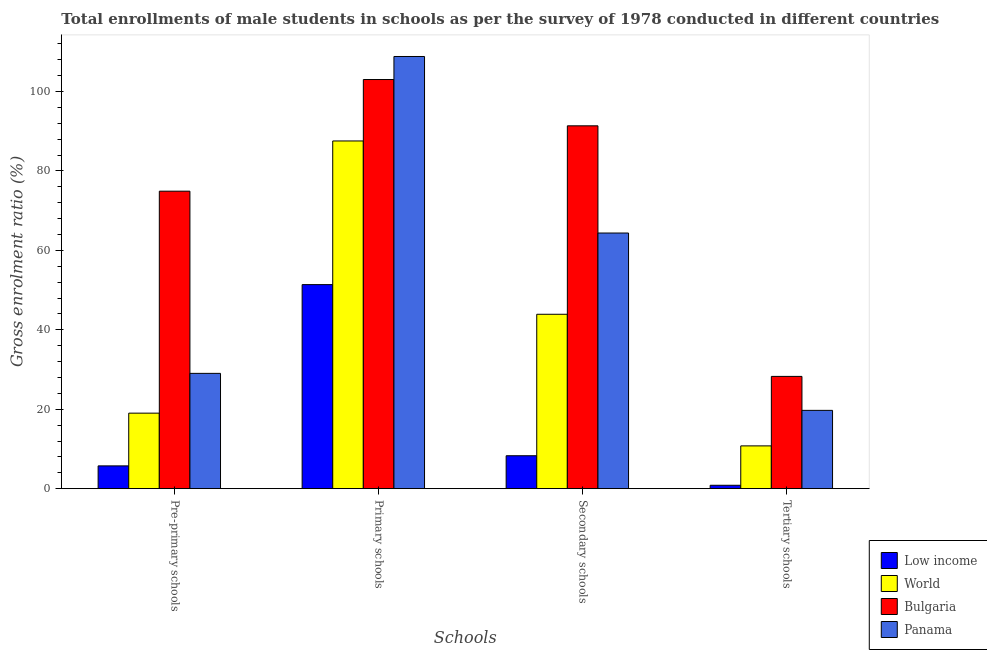How many different coloured bars are there?
Your response must be concise. 4. Are the number of bars on each tick of the X-axis equal?
Give a very brief answer. Yes. How many bars are there on the 3rd tick from the left?
Offer a terse response. 4. What is the label of the 4th group of bars from the left?
Your answer should be compact. Tertiary schools. What is the gross enrolment ratio(male) in pre-primary schools in Panama?
Provide a succinct answer. 29.03. Across all countries, what is the maximum gross enrolment ratio(male) in pre-primary schools?
Keep it short and to the point. 74.89. Across all countries, what is the minimum gross enrolment ratio(male) in secondary schools?
Your answer should be very brief. 8.29. What is the total gross enrolment ratio(male) in tertiary schools in the graph?
Your response must be concise. 59.61. What is the difference between the gross enrolment ratio(male) in primary schools in World and that in Low income?
Keep it short and to the point. 36.16. What is the difference between the gross enrolment ratio(male) in primary schools in Panama and the gross enrolment ratio(male) in secondary schools in World?
Your response must be concise. 64.9. What is the average gross enrolment ratio(male) in primary schools per country?
Your response must be concise. 87.68. What is the difference between the gross enrolment ratio(male) in tertiary schools and gross enrolment ratio(male) in secondary schools in Bulgaria?
Your answer should be compact. -63.08. In how many countries, is the gross enrolment ratio(male) in tertiary schools greater than 88 %?
Your response must be concise. 0. What is the ratio of the gross enrolment ratio(male) in secondary schools in Low income to that in World?
Your answer should be compact. 0.19. Is the difference between the gross enrolment ratio(male) in secondary schools in World and Low income greater than the difference between the gross enrolment ratio(male) in primary schools in World and Low income?
Your answer should be compact. No. What is the difference between the highest and the second highest gross enrolment ratio(male) in secondary schools?
Offer a very short reply. 26.99. What is the difference between the highest and the lowest gross enrolment ratio(male) in pre-primary schools?
Your response must be concise. 69.15. In how many countries, is the gross enrolment ratio(male) in pre-primary schools greater than the average gross enrolment ratio(male) in pre-primary schools taken over all countries?
Your response must be concise. 1. Is the sum of the gross enrolment ratio(male) in pre-primary schools in Bulgaria and World greater than the maximum gross enrolment ratio(male) in primary schools across all countries?
Your answer should be compact. No. What does the 2nd bar from the left in Tertiary schools represents?
Offer a very short reply. World. How many bars are there?
Keep it short and to the point. 16. What is the difference between two consecutive major ticks on the Y-axis?
Make the answer very short. 20. Are the values on the major ticks of Y-axis written in scientific E-notation?
Offer a terse response. No. Where does the legend appear in the graph?
Provide a succinct answer. Bottom right. How many legend labels are there?
Your response must be concise. 4. How are the legend labels stacked?
Provide a succinct answer. Vertical. What is the title of the graph?
Offer a terse response. Total enrollments of male students in schools as per the survey of 1978 conducted in different countries. Does "Georgia" appear as one of the legend labels in the graph?
Offer a terse response. No. What is the label or title of the X-axis?
Your response must be concise. Schools. What is the Gross enrolment ratio (%) of Low income in Pre-primary schools?
Your answer should be compact. 5.74. What is the Gross enrolment ratio (%) of World in Pre-primary schools?
Give a very brief answer. 19.01. What is the Gross enrolment ratio (%) in Bulgaria in Pre-primary schools?
Your answer should be compact. 74.89. What is the Gross enrolment ratio (%) in Panama in Pre-primary schools?
Provide a succinct answer. 29.03. What is the Gross enrolment ratio (%) of Low income in Primary schools?
Keep it short and to the point. 51.37. What is the Gross enrolment ratio (%) of World in Primary schools?
Your response must be concise. 87.53. What is the Gross enrolment ratio (%) in Bulgaria in Primary schools?
Your answer should be very brief. 103. What is the Gross enrolment ratio (%) of Panama in Primary schools?
Keep it short and to the point. 108.8. What is the Gross enrolment ratio (%) of Low income in Secondary schools?
Offer a terse response. 8.29. What is the Gross enrolment ratio (%) of World in Secondary schools?
Provide a succinct answer. 43.9. What is the Gross enrolment ratio (%) in Bulgaria in Secondary schools?
Ensure brevity in your answer.  91.35. What is the Gross enrolment ratio (%) of Panama in Secondary schools?
Offer a very short reply. 64.36. What is the Gross enrolment ratio (%) in Low income in Tertiary schools?
Keep it short and to the point. 0.86. What is the Gross enrolment ratio (%) in World in Tertiary schools?
Ensure brevity in your answer.  10.77. What is the Gross enrolment ratio (%) of Bulgaria in Tertiary schools?
Give a very brief answer. 28.26. What is the Gross enrolment ratio (%) in Panama in Tertiary schools?
Your response must be concise. 19.71. Across all Schools, what is the maximum Gross enrolment ratio (%) of Low income?
Make the answer very short. 51.37. Across all Schools, what is the maximum Gross enrolment ratio (%) of World?
Ensure brevity in your answer.  87.53. Across all Schools, what is the maximum Gross enrolment ratio (%) in Bulgaria?
Make the answer very short. 103. Across all Schools, what is the maximum Gross enrolment ratio (%) of Panama?
Provide a succinct answer. 108.8. Across all Schools, what is the minimum Gross enrolment ratio (%) of Low income?
Offer a terse response. 0.86. Across all Schools, what is the minimum Gross enrolment ratio (%) of World?
Your response must be concise. 10.77. Across all Schools, what is the minimum Gross enrolment ratio (%) of Bulgaria?
Your response must be concise. 28.26. Across all Schools, what is the minimum Gross enrolment ratio (%) of Panama?
Your answer should be compact. 19.71. What is the total Gross enrolment ratio (%) of Low income in the graph?
Provide a short and direct response. 66.26. What is the total Gross enrolment ratio (%) of World in the graph?
Keep it short and to the point. 161.23. What is the total Gross enrolment ratio (%) in Bulgaria in the graph?
Offer a terse response. 297.5. What is the total Gross enrolment ratio (%) in Panama in the graph?
Your response must be concise. 221.9. What is the difference between the Gross enrolment ratio (%) in Low income in Pre-primary schools and that in Primary schools?
Give a very brief answer. -45.63. What is the difference between the Gross enrolment ratio (%) of World in Pre-primary schools and that in Primary schools?
Your response must be concise. -68.52. What is the difference between the Gross enrolment ratio (%) in Bulgaria in Pre-primary schools and that in Primary schools?
Offer a very short reply. -28.11. What is the difference between the Gross enrolment ratio (%) in Panama in Pre-primary schools and that in Primary schools?
Ensure brevity in your answer.  -79.77. What is the difference between the Gross enrolment ratio (%) in Low income in Pre-primary schools and that in Secondary schools?
Give a very brief answer. -2.55. What is the difference between the Gross enrolment ratio (%) of World in Pre-primary schools and that in Secondary schools?
Provide a short and direct response. -24.89. What is the difference between the Gross enrolment ratio (%) of Bulgaria in Pre-primary schools and that in Secondary schools?
Provide a succinct answer. -16.46. What is the difference between the Gross enrolment ratio (%) of Panama in Pre-primary schools and that in Secondary schools?
Provide a short and direct response. -35.33. What is the difference between the Gross enrolment ratio (%) in Low income in Pre-primary schools and that in Tertiary schools?
Offer a very short reply. 4.88. What is the difference between the Gross enrolment ratio (%) of World in Pre-primary schools and that in Tertiary schools?
Offer a terse response. 8.24. What is the difference between the Gross enrolment ratio (%) of Bulgaria in Pre-primary schools and that in Tertiary schools?
Make the answer very short. 46.63. What is the difference between the Gross enrolment ratio (%) of Panama in Pre-primary schools and that in Tertiary schools?
Keep it short and to the point. 9.31. What is the difference between the Gross enrolment ratio (%) of Low income in Primary schools and that in Secondary schools?
Provide a succinct answer. 43.08. What is the difference between the Gross enrolment ratio (%) of World in Primary schools and that in Secondary schools?
Provide a short and direct response. 43.63. What is the difference between the Gross enrolment ratio (%) of Bulgaria in Primary schools and that in Secondary schools?
Offer a very short reply. 11.65. What is the difference between the Gross enrolment ratio (%) of Panama in Primary schools and that in Secondary schools?
Give a very brief answer. 44.44. What is the difference between the Gross enrolment ratio (%) in Low income in Primary schools and that in Tertiary schools?
Provide a succinct answer. 50.51. What is the difference between the Gross enrolment ratio (%) in World in Primary schools and that in Tertiary schools?
Your answer should be compact. 76.76. What is the difference between the Gross enrolment ratio (%) in Bulgaria in Primary schools and that in Tertiary schools?
Ensure brevity in your answer.  74.74. What is the difference between the Gross enrolment ratio (%) in Panama in Primary schools and that in Tertiary schools?
Your response must be concise. 89.09. What is the difference between the Gross enrolment ratio (%) in Low income in Secondary schools and that in Tertiary schools?
Ensure brevity in your answer.  7.43. What is the difference between the Gross enrolment ratio (%) of World in Secondary schools and that in Tertiary schools?
Make the answer very short. 33.13. What is the difference between the Gross enrolment ratio (%) in Bulgaria in Secondary schools and that in Tertiary schools?
Ensure brevity in your answer.  63.08. What is the difference between the Gross enrolment ratio (%) in Panama in Secondary schools and that in Tertiary schools?
Ensure brevity in your answer.  44.64. What is the difference between the Gross enrolment ratio (%) in Low income in Pre-primary schools and the Gross enrolment ratio (%) in World in Primary schools?
Provide a short and direct response. -81.8. What is the difference between the Gross enrolment ratio (%) of Low income in Pre-primary schools and the Gross enrolment ratio (%) of Bulgaria in Primary schools?
Your answer should be very brief. -97.26. What is the difference between the Gross enrolment ratio (%) of Low income in Pre-primary schools and the Gross enrolment ratio (%) of Panama in Primary schools?
Your response must be concise. -103.06. What is the difference between the Gross enrolment ratio (%) in World in Pre-primary schools and the Gross enrolment ratio (%) in Bulgaria in Primary schools?
Your answer should be compact. -83.99. What is the difference between the Gross enrolment ratio (%) in World in Pre-primary schools and the Gross enrolment ratio (%) in Panama in Primary schools?
Your answer should be very brief. -89.79. What is the difference between the Gross enrolment ratio (%) in Bulgaria in Pre-primary schools and the Gross enrolment ratio (%) in Panama in Primary schools?
Offer a terse response. -33.91. What is the difference between the Gross enrolment ratio (%) of Low income in Pre-primary schools and the Gross enrolment ratio (%) of World in Secondary schools?
Offer a terse response. -38.17. What is the difference between the Gross enrolment ratio (%) of Low income in Pre-primary schools and the Gross enrolment ratio (%) of Bulgaria in Secondary schools?
Keep it short and to the point. -85.61. What is the difference between the Gross enrolment ratio (%) in Low income in Pre-primary schools and the Gross enrolment ratio (%) in Panama in Secondary schools?
Provide a short and direct response. -58.62. What is the difference between the Gross enrolment ratio (%) of World in Pre-primary schools and the Gross enrolment ratio (%) of Bulgaria in Secondary schools?
Offer a very short reply. -72.33. What is the difference between the Gross enrolment ratio (%) in World in Pre-primary schools and the Gross enrolment ratio (%) in Panama in Secondary schools?
Keep it short and to the point. -45.34. What is the difference between the Gross enrolment ratio (%) in Bulgaria in Pre-primary schools and the Gross enrolment ratio (%) in Panama in Secondary schools?
Offer a terse response. 10.53. What is the difference between the Gross enrolment ratio (%) in Low income in Pre-primary schools and the Gross enrolment ratio (%) in World in Tertiary schools?
Ensure brevity in your answer.  -5.04. What is the difference between the Gross enrolment ratio (%) of Low income in Pre-primary schools and the Gross enrolment ratio (%) of Bulgaria in Tertiary schools?
Your response must be concise. -22.53. What is the difference between the Gross enrolment ratio (%) in Low income in Pre-primary schools and the Gross enrolment ratio (%) in Panama in Tertiary schools?
Provide a succinct answer. -13.98. What is the difference between the Gross enrolment ratio (%) in World in Pre-primary schools and the Gross enrolment ratio (%) in Bulgaria in Tertiary schools?
Provide a succinct answer. -9.25. What is the difference between the Gross enrolment ratio (%) in World in Pre-primary schools and the Gross enrolment ratio (%) in Panama in Tertiary schools?
Give a very brief answer. -0.7. What is the difference between the Gross enrolment ratio (%) of Bulgaria in Pre-primary schools and the Gross enrolment ratio (%) of Panama in Tertiary schools?
Offer a very short reply. 55.18. What is the difference between the Gross enrolment ratio (%) of Low income in Primary schools and the Gross enrolment ratio (%) of World in Secondary schools?
Offer a terse response. 7.47. What is the difference between the Gross enrolment ratio (%) in Low income in Primary schools and the Gross enrolment ratio (%) in Bulgaria in Secondary schools?
Ensure brevity in your answer.  -39.98. What is the difference between the Gross enrolment ratio (%) in Low income in Primary schools and the Gross enrolment ratio (%) in Panama in Secondary schools?
Make the answer very short. -12.99. What is the difference between the Gross enrolment ratio (%) of World in Primary schools and the Gross enrolment ratio (%) of Bulgaria in Secondary schools?
Your response must be concise. -3.81. What is the difference between the Gross enrolment ratio (%) in World in Primary schools and the Gross enrolment ratio (%) in Panama in Secondary schools?
Make the answer very short. 23.18. What is the difference between the Gross enrolment ratio (%) of Bulgaria in Primary schools and the Gross enrolment ratio (%) of Panama in Secondary schools?
Offer a terse response. 38.64. What is the difference between the Gross enrolment ratio (%) in Low income in Primary schools and the Gross enrolment ratio (%) in World in Tertiary schools?
Provide a short and direct response. 40.6. What is the difference between the Gross enrolment ratio (%) in Low income in Primary schools and the Gross enrolment ratio (%) in Bulgaria in Tertiary schools?
Your response must be concise. 23.11. What is the difference between the Gross enrolment ratio (%) of Low income in Primary schools and the Gross enrolment ratio (%) of Panama in Tertiary schools?
Provide a short and direct response. 31.66. What is the difference between the Gross enrolment ratio (%) of World in Primary schools and the Gross enrolment ratio (%) of Bulgaria in Tertiary schools?
Provide a short and direct response. 59.27. What is the difference between the Gross enrolment ratio (%) in World in Primary schools and the Gross enrolment ratio (%) in Panama in Tertiary schools?
Provide a short and direct response. 67.82. What is the difference between the Gross enrolment ratio (%) of Bulgaria in Primary schools and the Gross enrolment ratio (%) of Panama in Tertiary schools?
Your answer should be very brief. 83.29. What is the difference between the Gross enrolment ratio (%) of Low income in Secondary schools and the Gross enrolment ratio (%) of World in Tertiary schools?
Ensure brevity in your answer.  -2.48. What is the difference between the Gross enrolment ratio (%) in Low income in Secondary schools and the Gross enrolment ratio (%) in Bulgaria in Tertiary schools?
Offer a terse response. -19.97. What is the difference between the Gross enrolment ratio (%) of Low income in Secondary schools and the Gross enrolment ratio (%) of Panama in Tertiary schools?
Make the answer very short. -11.42. What is the difference between the Gross enrolment ratio (%) of World in Secondary schools and the Gross enrolment ratio (%) of Bulgaria in Tertiary schools?
Your response must be concise. 15.64. What is the difference between the Gross enrolment ratio (%) in World in Secondary schools and the Gross enrolment ratio (%) in Panama in Tertiary schools?
Make the answer very short. 24.19. What is the difference between the Gross enrolment ratio (%) of Bulgaria in Secondary schools and the Gross enrolment ratio (%) of Panama in Tertiary schools?
Offer a terse response. 71.63. What is the average Gross enrolment ratio (%) in Low income per Schools?
Offer a terse response. 16.56. What is the average Gross enrolment ratio (%) in World per Schools?
Offer a very short reply. 40.31. What is the average Gross enrolment ratio (%) in Bulgaria per Schools?
Provide a succinct answer. 74.38. What is the average Gross enrolment ratio (%) in Panama per Schools?
Your answer should be compact. 55.48. What is the difference between the Gross enrolment ratio (%) of Low income and Gross enrolment ratio (%) of World in Pre-primary schools?
Keep it short and to the point. -13.28. What is the difference between the Gross enrolment ratio (%) of Low income and Gross enrolment ratio (%) of Bulgaria in Pre-primary schools?
Make the answer very short. -69.15. What is the difference between the Gross enrolment ratio (%) of Low income and Gross enrolment ratio (%) of Panama in Pre-primary schools?
Your answer should be compact. -23.29. What is the difference between the Gross enrolment ratio (%) in World and Gross enrolment ratio (%) in Bulgaria in Pre-primary schools?
Offer a very short reply. -55.88. What is the difference between the Gross enrolment ratio (%) in World and Gross enrolment ratio (%) in Panama in Pre-primary schools?
Your answer should be very brief. -10.01. What is the difference between the Gross enrolment ratio (%) in Bulgaria and Gross enrolment ratio (%) in Panama in Pre-primary schools?
Provide a succinct answer. 45.86. What is the difference between the Gross enrolment ratio (%) in Low income and Gross enrolment ratio (%) in World in Primary schools?
Your answer should be very brief. -36.16. What is the difference between the Gross enrolment ratio (%) in Low income and Gross enrolment ratio (%) in Bulgaria in Primary schools?
Provide a succinct answer. -51.63. What is the difference between the Gross enrolment ratio (%) of Low income and Gross enrolment ratio (%) of Panama in Primary schools?
Your answer should be very brief. -57.43. What is the difference between the Gross enrolment ratio (%) in World and Gross enrolment ratio (%) in Bulgaria in Primary schools?
Your response must be concise. -15.47. What is the difference between the Gross enrolment ratio (%) in World and Gross enrolment ratio (%) in Panama in Primary schools?
Your answer should be compact. -21.27. What is the difference between the Gross enrolment ratio (%) in Bulgaria and Gross enrolment ratio (%) in Panama in Primary schools?
Your response must be concise. -5.8. What is the difference between the Gross enrolment ratio (%) in Low income and Gross enrolment ratio (%) in World in Secondary schools?
Your answer should be very brief. -35.61. What is the difference between the Gross enrolment ratio (%) of Low income and Gross enrolment ratio (%) of Bulgaria in Secondary schools?
Keep it short and to the point. -83.06. What is the difference between the Gross enrolment ratio (%) of Low income and Gross enrolment ratio (%) of Panama in Secondary schools?
Ensure brevity in your answer.  -56.07. What is the difference between the Gross enrolment ratio (%) of World and Gross enrolment ratio (%) of Bulgaria in Secondary schools?
Keep it short and to the point. -47.44. What is the difference between the Gross enrolment ratio (%) of World and Gross enrolment ratio (%) of Panama in Secondary schools?
Keep it short and to the point. -20.45. What is the difference between the Gross enrolment ratio (%) in Bulgaria and Gross enrolment ratio (%) in Panama in Secondary schools?
Your answer should be very brief. 26.99. What is the difference between the Gross enrolment ratio (%) in Low income and Gross enrolment ratio (%) in World in Tertiary schools?
Your answer should be compact. -9.91. What is the difference between the Gross enrolment ratio (%) of Low income and Gross enrolment ratio (%) of Bulgaria in Tertiary schools?
Your answer should be very brief. -27.41. What is the difference between the Gross enrolment ratio (%) of Low income and Gross enrolment ratio (%) of Panama in Tertiary schools?
Offer a very short reply. -18.86. What is the difference between the Gross enrolment ratio (%) in World and Gross enrolment ratio (%) in Bulgaria in Tertiary schools?
Provide a succinct answer. -17.49. What is the difference between the Gross enrolment ratio (%) of World and Gross enrolment ratio (%) of Panama in Tertiary schools?
Keep it short and to the point. -8.94. What is the difference between the Gross enrolment ratio (%) in Bulgaria and Gross enrolment ratio (%) in Panama in Tertiary schools?
Provide a short and direct response. 8.55. What is the ratio of the Gross enrolment ratio (%) of Low income in Pre-primary schools to that in Primary schools?
Ensure brevity in your answer.  0.11. What is the ratio of the Gross enrolment ratio (%) of World in Pre-primary schools to that in Primary schools?
Keep it short and to the point. 0.22. What is the ratio of the Gross enrolment ratio (%) of Bulgaria in Pre-primary schools to that in Primary schools?
Your answer should be compact. 0.73. What is the ratio of the Gross enrolment ratio (%) in Panama in Pre-primary schools to that in Primary schools?
Your answer should be very brief. 0.27. What is the ratio of the Gross enrolment ratio (%) in Low income in Pre-primary schools to that in Secondary schools?
Ensure brevity in your answer.  0.69. What is the ratio of the Gross enrolment ratio (%) of World in Pre-primary schools to that in Secondary schools?
Make the answer very short. 0.43. What is the ratio of the Gross enrolment ratio (%) of Bulgaria in Pre-primary schools to that in Secondary schools?
Provide a succinct answer. 0.82. What is the ratio of the Gross enrolment ratio (%) in Panama in Pre-primary schools to that in Secondary schools?
Offer a very short reply. 0.45. What is the ratio of the Gross enrolment ratio (%) of Low income in Pre-primary schools to that in Tertiary schools?
Ensure brevity in your answer.  6.69. What is the ratio of the Gross enrolment ratio (%) of World in Pre-primary schools to that in Tertiary schools?
Provide a succinct answer. 1.77. What is the ratio of the Gross enrolment ratio (%) of Bulgaria in Pre-primary schools to that in Tertiary schools?
Your answer should be compact. 2.65. What is the ratio of the Gross enrolment ratio (%) of Panama in Pre-primary schools to that in Tertiary schools?
Provide a succinct answer. 1.47. What is the ratio of the Gross enrolment ratio (%) in Low income in Primary schools to that in Secondary schools?
Your answer should be compact. 6.2. What is the ratio of the Gross enrolment ratio (%) of World in Primary schools to that in Secondary schools?
Provide a short and direct response. 1.99. What is the ratio of the Gross enrolment ratio (%) of Bulgaria in Primary schools to that in Secondary schools?
Offer a terse response. 1.13. What is the ratio of the Gross enrolment ratio (%) in Panama in Primary schools to that in Secondary schools?
Your response must be concise. 1.69. What is the ratio of the Gross enrolment ratio (%) in Low income in Primary schools to that in Tertiary schools?
Provide a short and direct response. 59.86. What is the ratio of the Gross enrolment ratio (%) of World in Primary schools to that in Tertiary schools?
Give a very brief answer. 8.13. What is the ratio of the Gross enrolment ratio (%) in Bulgaria in Primary schools to that in Tertiary schools?
Ensure brevity in your answer.  3.64. What is the ratio of the Gross enrolment ratio (%) in Panama in Primary schools to that in Tertiary schools?
Keep it short and to the point. 5.52. What is the ratio of the Gross enrolment ratio (%) of Low income in Secondary schools to that in Tertiary schools?
Ensure brevity in your answer.  9.66. What is the ratio of the Gross enrolment ratio (%) in World in Secondary schools to that in Tertiary schools?
Provide a succinct answer. 4.08. What is the ratio of the Gross enrolment ratio (%) in Bulgaria in Secondary schools to that in Tertiary schools?
Your response must be concise. 3.23. What is the ratio of the Gross enrolment ratio (%) of Panama in Secondary schools to that in Tertiary schools?
Keep it short and to the point. 3.26. What is the difference between the highest and the second highest Gross enrolment ratio (%) in Low income?
Offer a terse response. 43.08. What is the difference between the highest and the second highest Gross enrolment ratio (%) in World?
Offer a terse response. 43.63. What is the difference between the highest and the second highest Gross enrolment ratio (%) in Bulgaria?
Your response must be concise. 11.65. What is the difference between the highest and the second highest Gross enrolment ratio (%) of Panama?
Offer a terse response. 44.44. What is the difference between the highest and the lowest Gross enrolment ratio (%) in Low income?
Ensure brevity in your answer.  50.51. What is the difference between the highest and the lowest Gross enrolment ratio (%) in World?
Provide a short and direct response. 76.76. What is the difference between the highest and the lowest Gross enrolment ratio (%) in Bulgaria?
Ensure brevity in your answer.  74.74. What is the difference between the highest and the lowest Gross enrolment ratio (%) of Panama?
Provide a succinct answer. 89.09. 